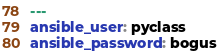Convert code to text. <code><loc_0><loc_0><loc_500><loc_500><_YAML_>---
ansible_user: pyclass
ansible_password: bogus
</code> 